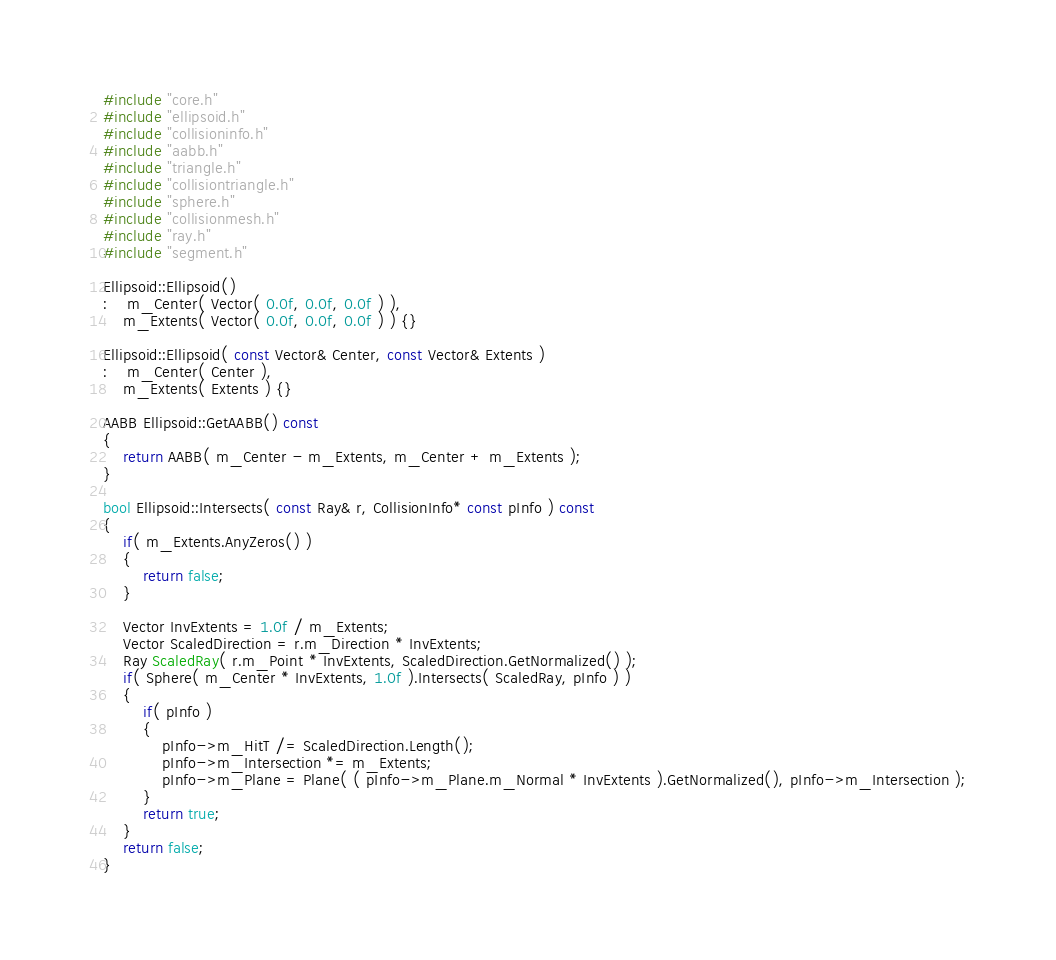<code> <loc_0><loc_0><loc_500><loc_500><_C++_>#include "core.h"
#include "ellipsoid.h"
#include "collisioninfo.h"
#include "aabb.h"
#include "triangle.h"
#include "collisiontriangle.h"
#include "sphere.h"
#include "collisionmesh.h"
#include "ray.h"
#include "segment.h"

Ellipsoid::Ellipsoid()
:	m_Center( Vector( 0.0f, 0.0f, 0.0f ) ),
	m_Extents( Vector( 0.0f, 0.0f, 0.0f ) ) {}

Ellipsoid::Ellipsoid( const Vector& Center, const Vector& Extents )
:	m_Center( Center ),
	m_Extents( Extents ) {}

AABB Ellipsoid::GetAABB() const
{
	return AABB( m_Center - m_Extents, m_Center + m_Extents );
}

bool Ellipsoid::Intersects( const Ray& r, CollisionInfo* const pInfo ) const
{
	if( m_Extents.AnyZeros() )
	{
		return false;
	}

	Vector InvExtents = 1.0f / m_Extents;
	Vector ScaledDirection = r.m_Direction * InvExtents;
	Ray ScaledRay( r.m_Point * InvExtents, ScaledDirection.GetNormalized() );
	if( Sphere( m_Center * InvExtents, 1.0f ).Intersects( ScaledRay, pInfo ) )
	{
		if( pInfo )
		{
			pInfo->m_HitT /= ScaledDirection.Length();
			pInfo->m_Intersection *= m_Extents;
			pInfo->m_Plane = Plane( ( pInfo->m_Plane.m_Normal * InvExtents ).GetNormalized(), pInfo->m_Intersection );
		}
		return true;
	}
	return false;
}
</code> 